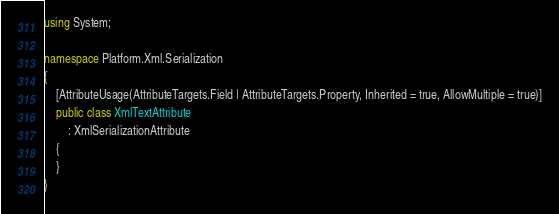<code> <loc_0><loc_0><loc_500><loc_500><_C#_>using System;

namespace Platform.Xml.Serialization
{
	[AttributeUsage(AttributeTargets.Field | AttributeTargets.Property, Inherited = true, AllowMultiple = true)]
	public class XmlTextAttribute
		: XmlSerializationAttribute
	{
	}
}</code> 